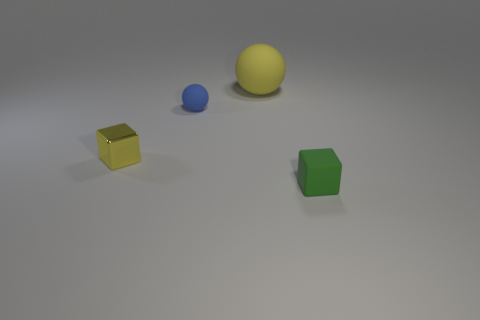Add 3 blue rubber balls. How many objects exist? 7 Add 3 tiny matte blocks. How many tiny matte blocks are left? 4 Add 1 yellow cubes. How many yellow cubes exist? 2 Subtract 0 red cylinders. How many objects are left? 4 Subtract all tiny things. Subtract all small cyan cylinders. How many objects are left? 1 